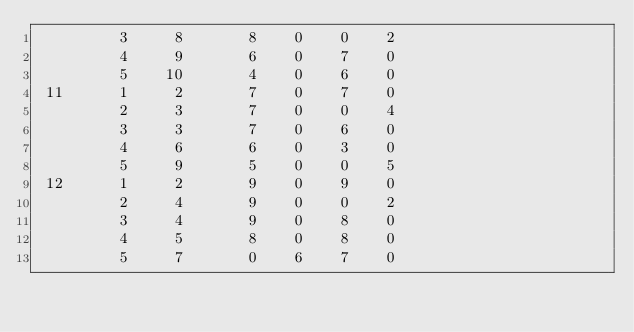Convert code to text. <code><loc_0><loc_0><loc_500><loc_500><_ObjectiveC_>         3     8       8    0    0    2
         4     9       6    0    7    0
         5    10       4    0    6    0
 11      1     2       7    0    7    0
         2     3       7    0    0    4
         3     3       7    0    6    0
         4     6       6    0    3    0
         5     9       5    0    0    5
 12      1     2       9    0    9    0
         2     4       9    0    0    2
         3     4       9    0    8    0
         4     5       8    0    8    0
         5     7       0    6    7    0</code> 